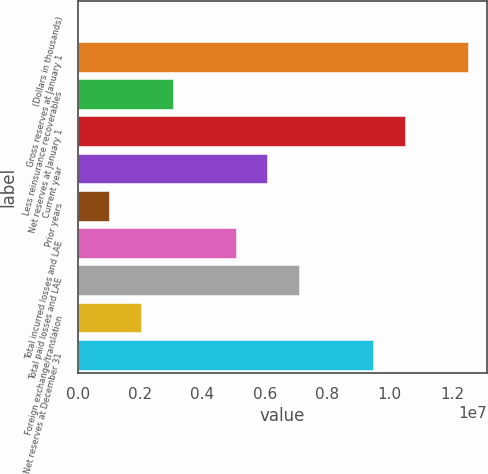Convert chart to OTSL. <chart><loc_0><loc_0><loc_500><loc_500><bar_chart><fcel>(Dollars in thousands)<fcel>Gross reserves at January 1<fcel>Less reinsurance recoverables<fcel>Net reserves at January 1<fcel>Current year<fcel>Prior years<fcel>Total incurred losses and LAE<fcel>Total paid losses and LAE<fcel>Foreign exchange/translation<fcel>Net reserves at December 31<nl><fcel>2012<fcel>1.25027e+07<fcel>3.03837e+06<fcel>1.04784e+07<fcel>6.07473e+06<fcel>1.01413e+06<fcel>5.06261e+06<fcel>7.08685e+06<fcel>2.02625e+06<fcel>9.4663e+06<nl></chart> 